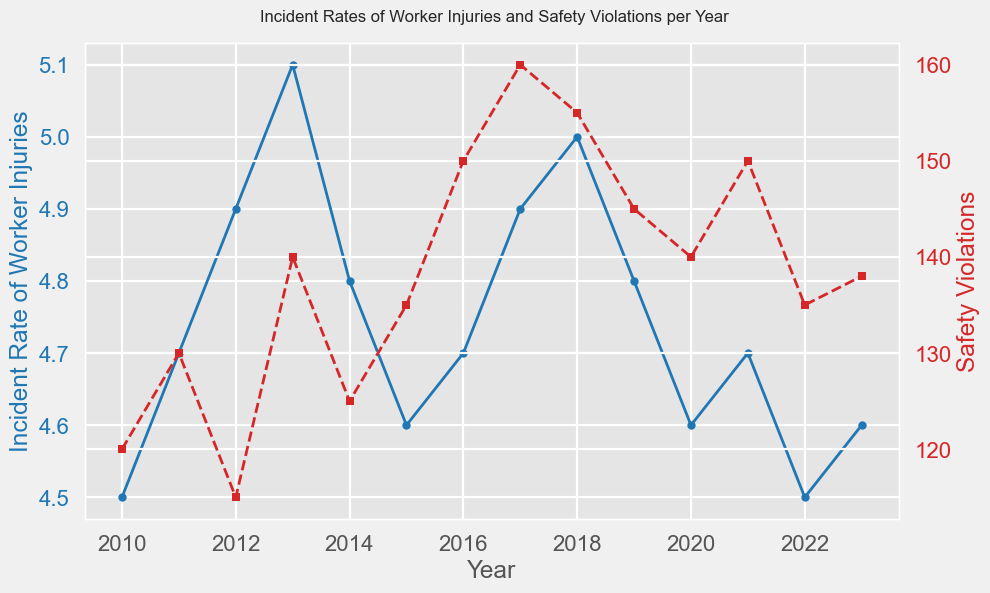What is the trend of the incident rate of worker injuries from 2010 to 2023? The incident rate of worker injuries initially increases from 4.5 in 2010 to 5.1 in 2013. It then fluctuates slightly but mainly trends downward, reaching 4.6 in 2023.
Answer: Downward with fluctuations Which year had the highest number of safety violations, and how many were there? By looking at the peaks in the red line, the highest number of safety violations occurred in 2017, with 160 violations.
Answer: 2017, 160 Compare the incident rate of worker injuries in 2013 and 2016. Which year was higher, and by how much? The incident rate in 2013 was 5.1, and in 2016 it was 4.7. The rate in 2013 was higher by 0.4.
Answer: 2013, 0.4 What is the average incident rate of worker injuries for the years shown in the chart? Add the injury rates for all years (4.5 + 4.7 + 4.9 + 5.1 + 4.8 + 4.6 + 4.7 + 4.9 + 5.0 + 4.8 + 4.6 + 4.7 + 4.5 + 4.6) and divide by 14 (number of years). Total is 65.4, so the average is 65.4/14 = 4.67.
Answer: 4.67 Which color line represents the safety violations, and what is its visual pattern compared to the worker injuries line? The safety violations line is represented in red and follows a more varied and increasing pattern as compared to the worker injuries line which is blue with smaller fluctuations.
Answer: Red, more varied and increasing Calculate the total number of safety violations recorded from 2015 to 2020 inclusively. Sum the safety violations from 2015 to 2020 (135 + 150 + 160 + 155 + 145 + 140). Total is (135 + 150 + 160 + 155 + 145 + 140) = 885.
Answer: 885 In which year was the incident rate of worker injuries equal to the safety violations? There is no year where the worker injuries rate exactly equals the number of safety violations by visual comparison.
Answer: None In which year did both the incident rate of worker injuries and safety violations increase compared to the previous year? Compare each year's worker injuries rate and safety violations to the previous year's values. In 2017, both incident rate (from 4.7 to 4.9) and safety violations (from 150 to 160) increased.
Answer: 2017 